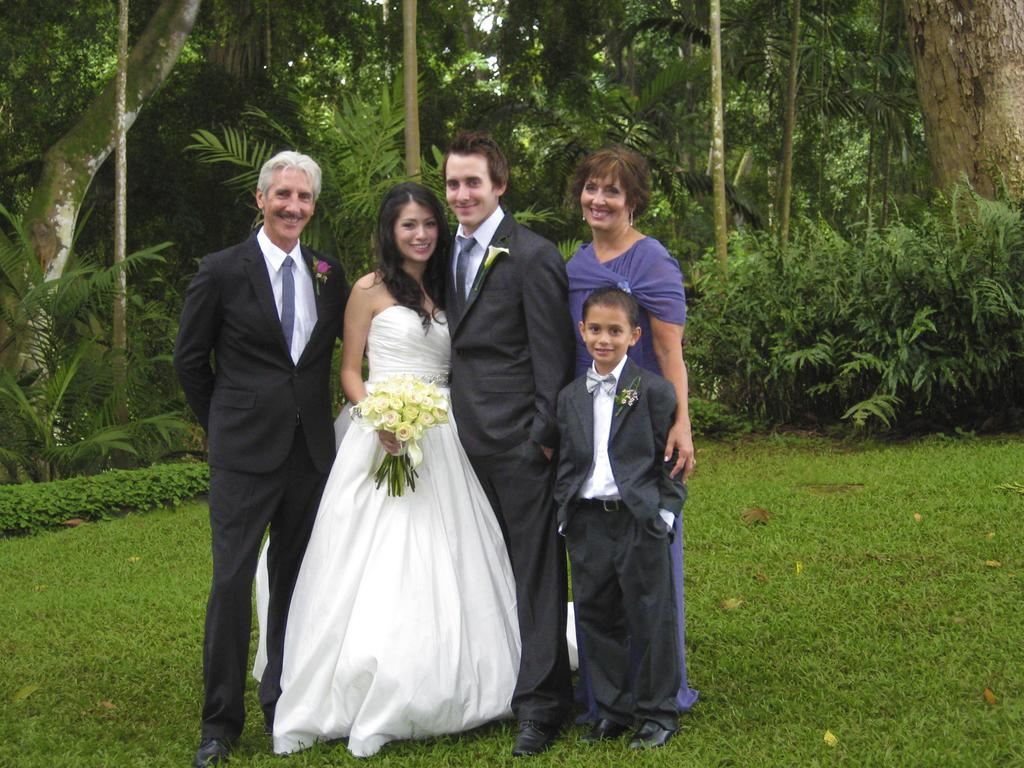What type of vegetation can be seen in the image? There is grass, plants, and trees in the image. Can you describe the group of people in the image? There is a group of people standing in the front of the image. What is the woman wearing in the image? The woman is wearing a white dress. What is the woman holding in the image? The woman is holding flowers. What type of thrill can be seen in the image? There is no thrill present in the image; it features a group of people, a woman in a white dress, and various types of vegetation. Can you identify any amusement park rides in the image? There are no amusement park rides present in the image. 